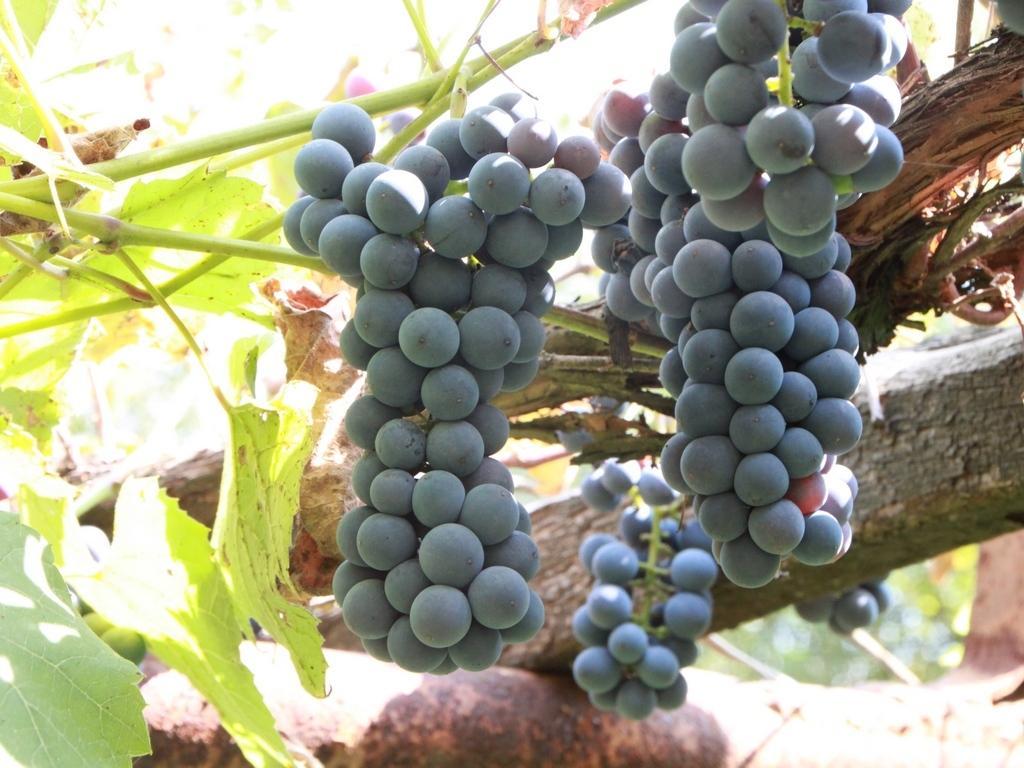Please provide a concise description of this image. In this picture we see a bunch of grapes on the branch of a tree with green leaves. 